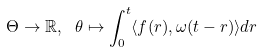<formula> <loc_0><loc_0><loc_500><loc_500>\Theta \rightarrow \mathbb { R } , \ \theta \mapsto \int _ { 0 } ^ { t } \langle f ( r ) , \omega ( t - r ) \rangle d r</formula> 